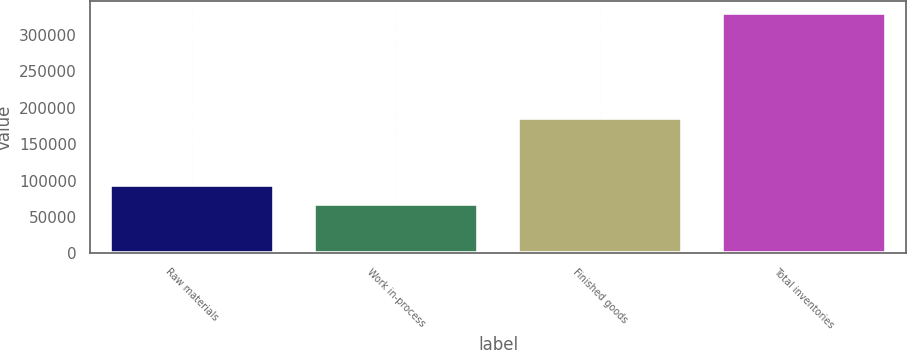Convert chart. <chart><loc_0><loc_0><loc_500><loc_500><bar_chart><fcel>Raw materials<fcel>Work in-process<fcel>Finished goods<fcel>Total inventories<nl><fcel>93819.2<fcel>67502<fcel>186237<fcel>330674<nl></chart> 